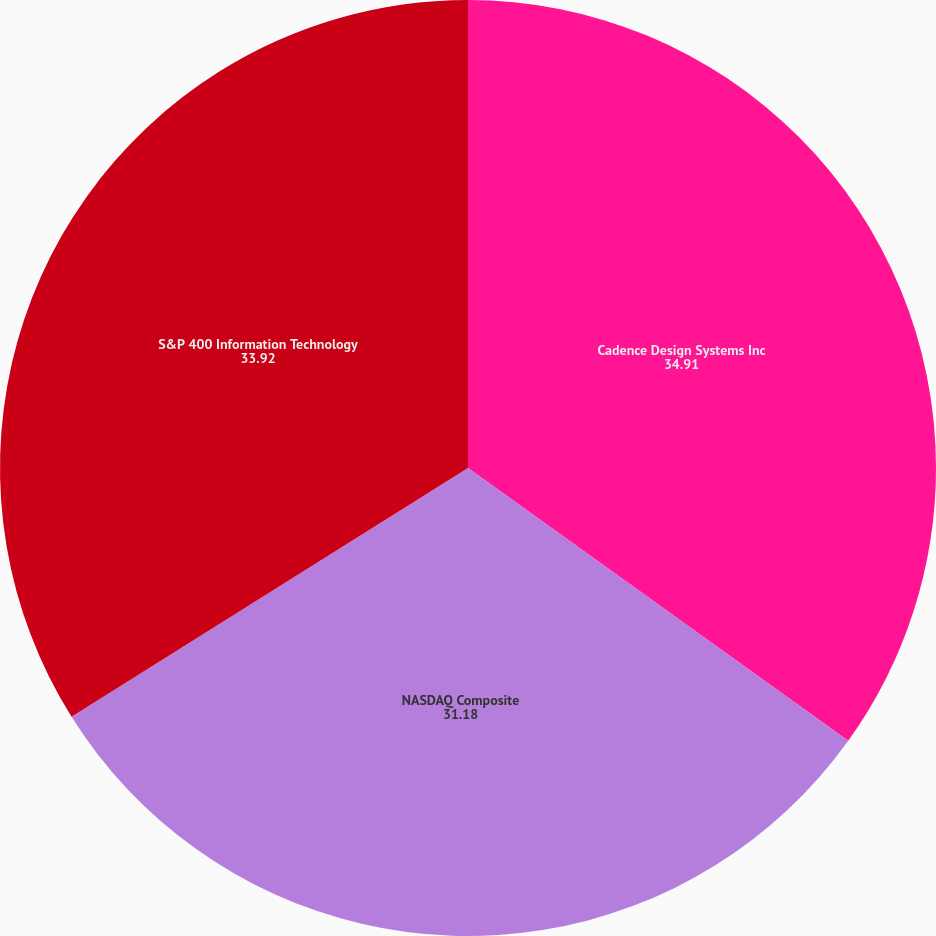Convert chart to OTSL. <chart><loc_0><loc_0><loc_500><loc_500><pie_chart><fcel>Cadence Design Systems Inc<fcel>NASDAQ Composite<fcel>S&P 400 Information Technology<nl><fcel>34.91%<fcel>31.18%<fcel>33.92%<nl></chart> 